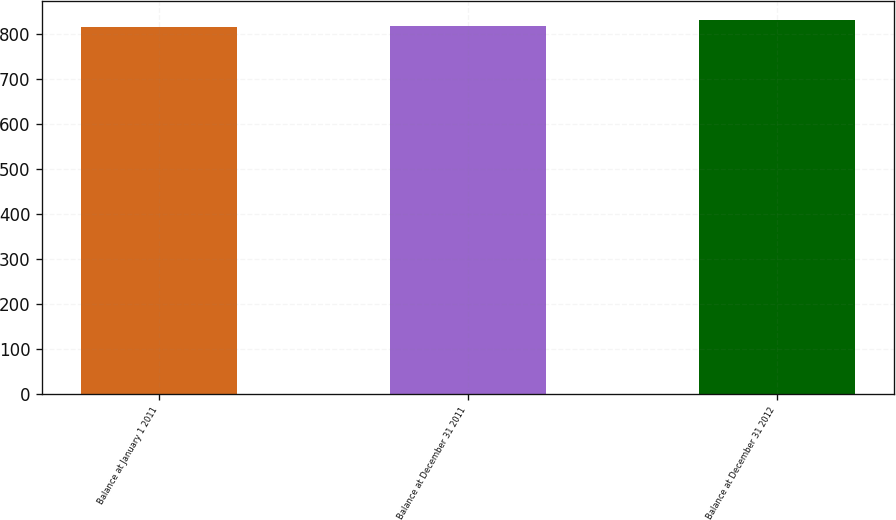Convert chart. <chart><loc_0><loc_0><loc_500><loc_500><bar_chart><fcel>Balance at January 1 2011<fcel>Balance at December 31 2011<fcel>Balance at December 31 2012<nl><fcel>815<fcel>818<fcel>830<nl></chart> 